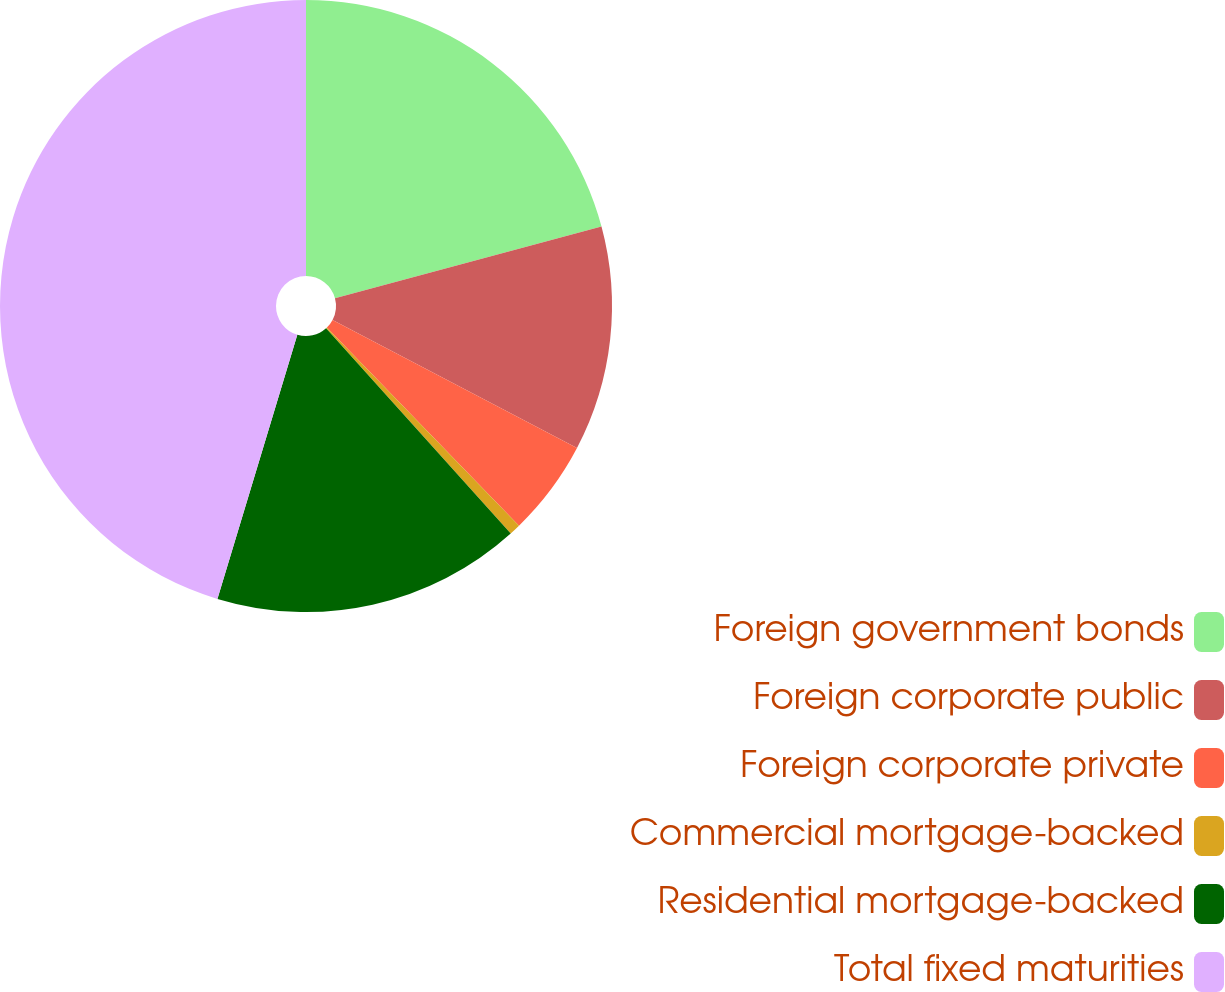Convert chart to OTSL. <chart><loc_0><loc_0><loc_500><loc_500><pie_chart><fcel>Foreign government bonds<fcel>Foreign corporate public<fcel>Foreign corporate private<fcel>Commercial mortgage-backed<fcel>Residential mortgage-backed<fcel>Total fixed maturities<nl><fcel>20.82%<fcel>11.87%<fcel>5.06%<fcel>0.59%<fcel>16.34%<fcel>45.33%<nl></chart> 